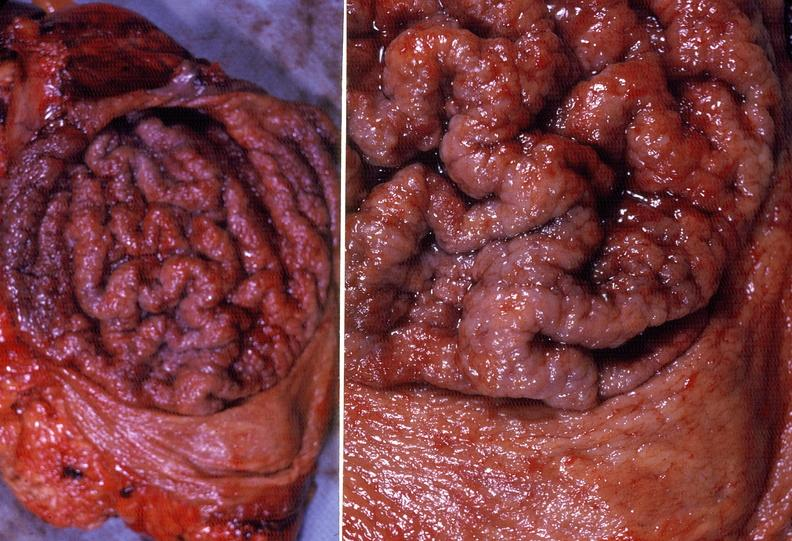what does this image show?
Answer the question using a single word or phrase. Stomach 